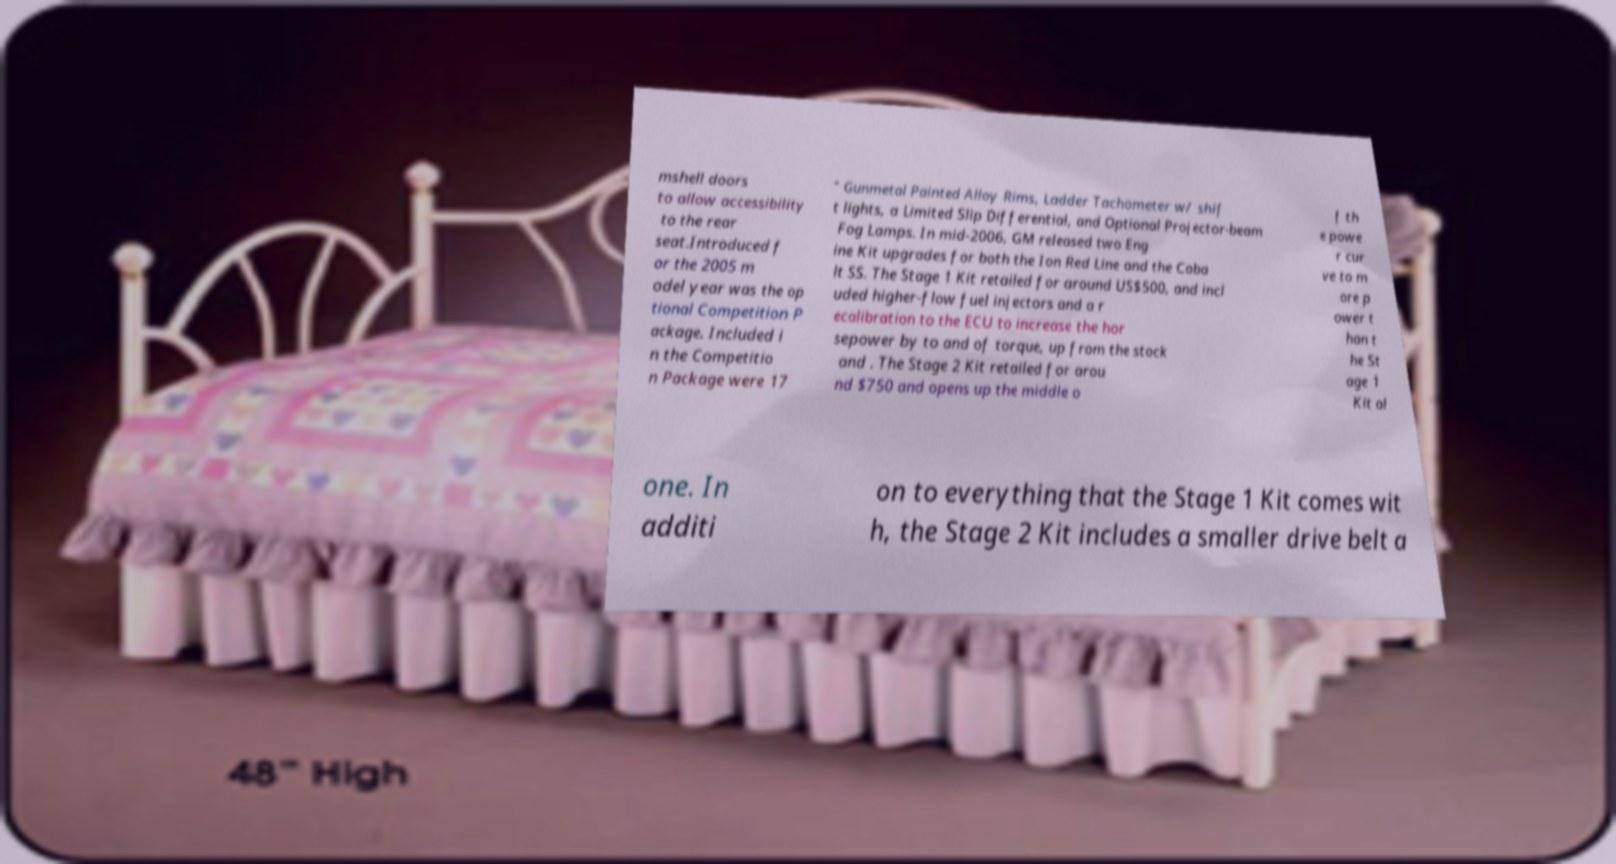For documentation purposes, I need the text within this image transcribed. Could you provide that? mshell doors to allow accessibility to the rear seat.Introduced f or the 2005 m odel year was the op tional Competition P ackage. Included i n the Competitio n Package were 17 " Gunmetal Painted Alloy Rims, Ladder Tachometer w/ shif t lights, a Limited Slip Differential, and Optional Projector-beam Fog Lamps. In mid-2006, GM released two Eng ine Kit upgrades for both the Ion Red Line and the Coba lt SS. The Stage 1 Kit retailed for around US$500, and incl uded higher-flow fuel injectors and a r ecalibration to the ECU to increase the hor sepower by to and of torque, up from the stock and . The Stage 2 Kit retailed for arou nd $750 and opens up the middle o f th e powe r cur ve to m ore p ower t han t he St age 1 Kit al one. In additi on to everything that the Stage 1 Kit comes wit h, the Stage 2 Kit includes a smaller drive belt a 